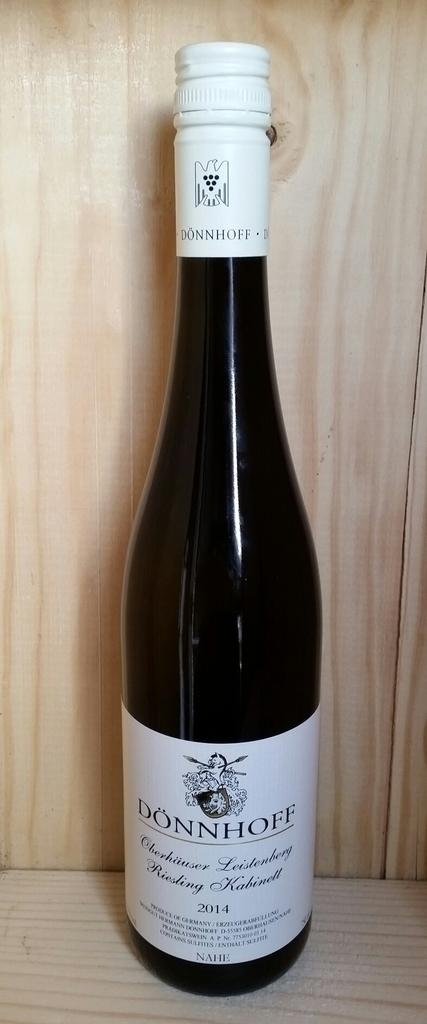<image>
Offer a succinct explanation of the picture presented. A bottlw of Dönnhoff wine sits on a light colored wooden shelf. 